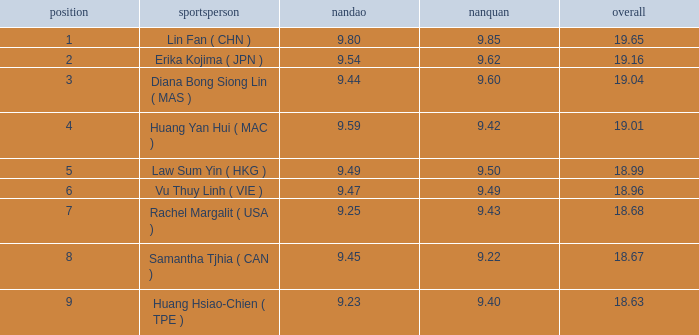Which Nanquan has a Nandao larger than 9.49, and a Rank of 4? 9.42. 